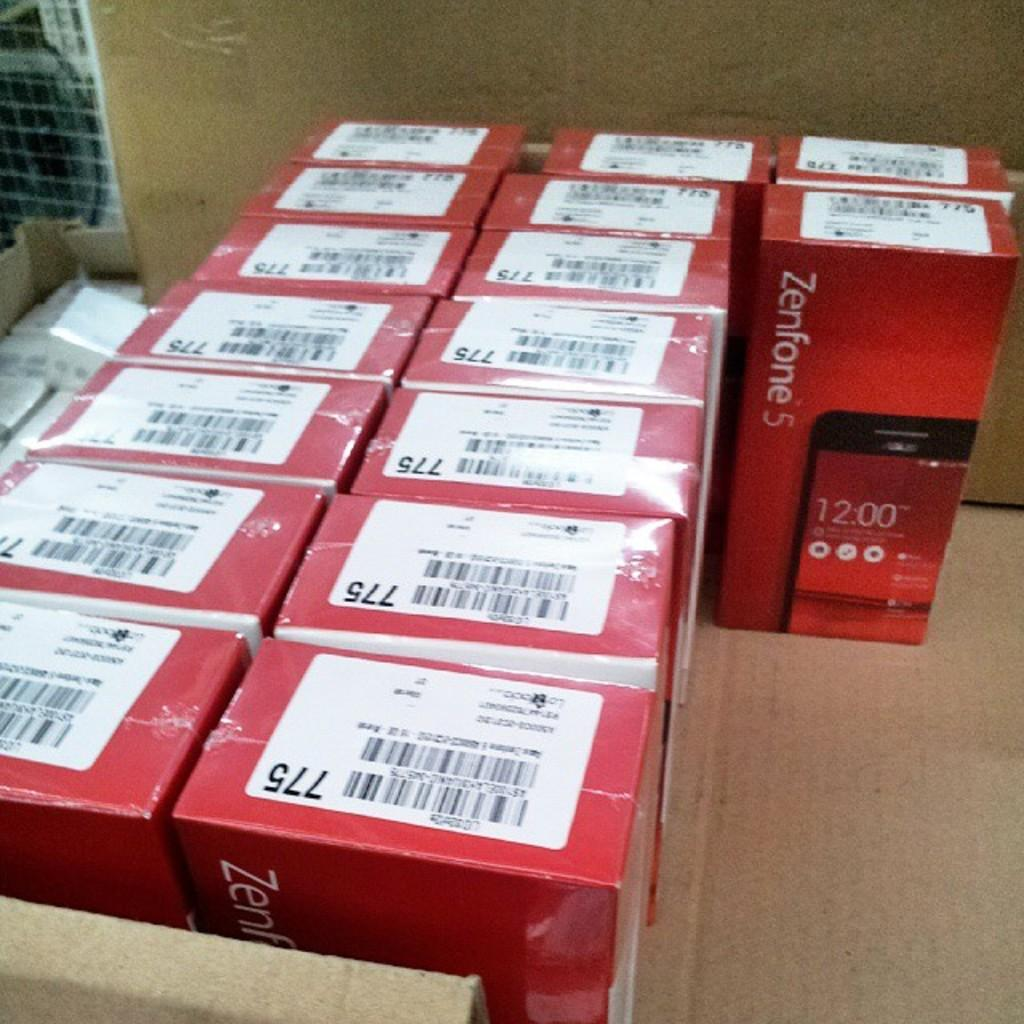<image>
Create a compact narrative representing the image presented. Red boxes with the name Zenfone 5 on the front packaged together. 